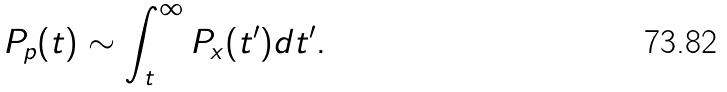Convert formula to latex. <formula><loc_0><loc_0><loc_500><loc_500>P _ { p } ( t ) \sim \int _ { t } ^ { \infty } P _ { x } ( t ^ { \prime } ) d t ^ { \prime } .</formula> 